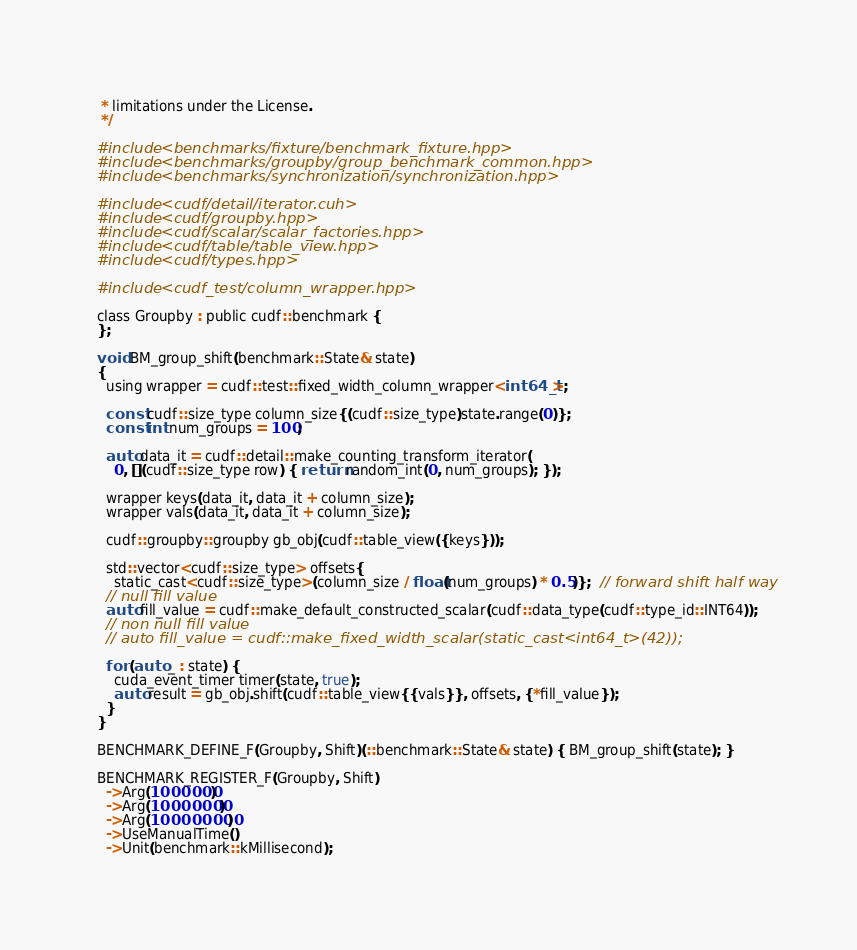<code> <loc_0><loc_0><loc_500><loc_500><_Cuda_> * limitations under the License.
 */

#include <benchmarks/fixture/benchmark_fixture.hpp>
#include <benchmarks/groupby/group_benchmark_common.hpp>
#include <benchmarks/synchronization/synchronization.hpp>

#include <cudf/detail/iterator.cuh>
#include <cudf/groupby.hpp>
#include <cudf/scalar/scalar_factories.hpp>
#include <cudf/table/table_view.hpp>
#include <cudf/types.hpp>

#include <cudf_test/column_wrapper.hpp>

class Groupby : public cudf::benchmark {
};

void BM_group_shift(benchmark::State& state)
{
  using wrapper = cudf::test::fixed_width_column_wrapper<int64_t>;

  const cudf::size_type column_size{(cudf::size_type)state.range(0)};
  const int num_groups = 100;

  auto data_it = cudf::detail::make_counting_transform_iterator(
    0, [](cudf::size_type row) { return random_int(0, num_groups); });

  wrapper keys(data_it, data_it + column_size);
  wrapper vals(data_it, data_it + column_size);

  cudf::groupby::groupby gb_obj(cudf::table_view({keys}));

  std::vector<cudf::size_type> offsets{
    static_cast<cudf::size_type>(column_size / float(num_groups) * 0.5)};  // forward shift half way
  // null fill value
  auto fill_value = cudf::make_default_constructed_scalar(cudf::data_type(cudf::type_id::INT64));
  // non null fill value
  // auto fill_value = cudf::make_fixed_width_scalar(static_cast<int64_t>(42));

  for (auto _ : state) {
    cuda_event_timer timer(state, true);
    auto result = gb_obj.shift(cudf::table_view{{vals}}, offsets, {*fill_value});
  }
}

BENCHMARK_DEFINE_F(Groupby, Shift)(::benchmark::State& state) { BM_group_shift(state); }

BENCHMARK_REGISTER_F(Groupby, Shift)
  ->Arg(1000000)
  ->Arg(10000000)
  ->Arg(100000000)
  ->UseManualTime()
  ->Unit(benchmark::kMillisecond);
</code> 